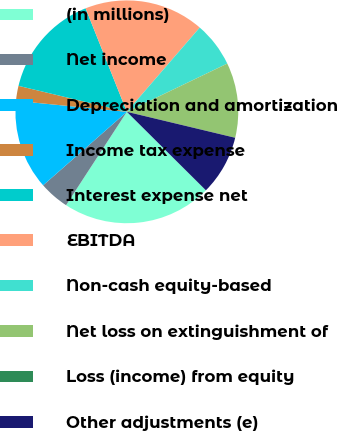Convert chart. <chart><loc_0><loc_0><loc_500><loc_500><pie_chart><fcel>(in millions)<fcel>Net income<fcel>Depreciation and amortization<fcel>Income tax expense<fcel>Interest expense net<fcel>EBITDA<fcel>Non-cash equity-based<fcel>Net loss on extinguishment of<fcel>Loss (income) from equity<fcel>Other adjustments (e)<nl><fcel>21.74%<fcel>4.35%<fcel>13.04%<fcel>2.17%<fcel>15.22%<fcel>17.39%<fcel>6.52%<fcel>10.87%<fcel>0.0%<fcel>8.7%<nl></chart> 